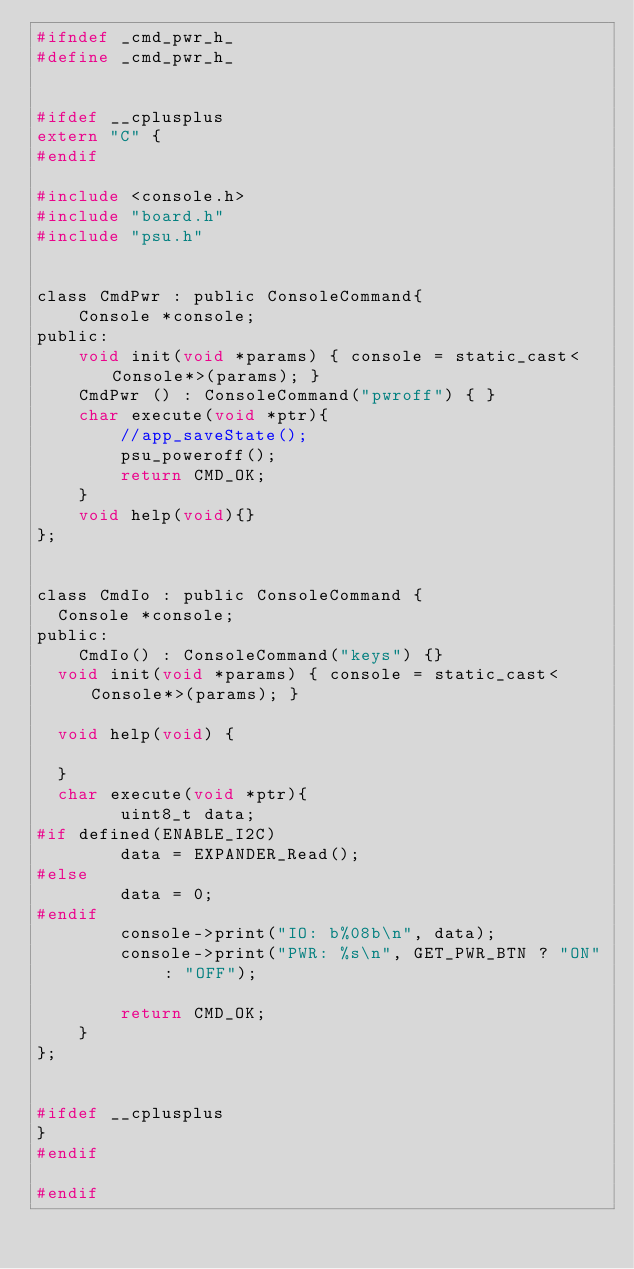Convert code to text. <code><loc_0><loc_0><loc_500><loc_500><_C_>#ifndef _cmd_pwr_h_
#define _cmd_pwr_h_


#ifdef __cplusplus
extern "C" {
#endif

#include <console.h>
#include "board.h"
#include "psu.h"


class CmdPwr : public ConsoleCommand{
    Console *console;
public:
    void init(void *params) { console = static_cast<Console*>(params); }
    CmdPwr () : ConsoleCommand("pwroff") { }
    char execute(void *ptr){
        //app_saveState();
        psu_poweroff();
        return CMD_OK;
    }
    void help(void){}
}; 


class CmdIo : public ConsoleCommand {
	Console *console;
public:
    CmdIo() : ConsoleCommand("keys") {}	
	void init(void *params) { console = static_cast<Console*>(params); }

	void help(void) {
		
	}
	char execute(void *ptr){
        uint8_t data;
#if defined(ENABLE_I2C)
        data = EXPANDER_Read();
#else
        data = 0;
#endif
        console->print("IO: b%08b\n", data);
        console->print("PWR: %s\n", GET_PWR_BTN ? "ON" : "OFF");

        return CMD_OK;
    }
};


#ifdef __cplusplus
}
#endif

#endif</code> 